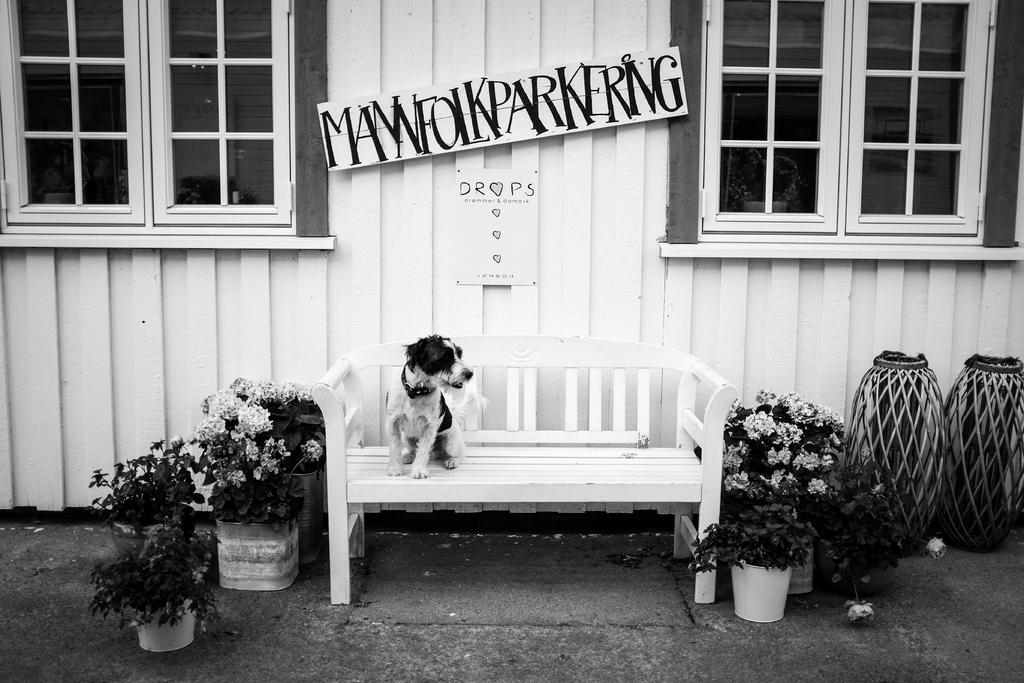What is the dog doing in the image? The dog is on a chair in the image. What other objects or elements can be seen in the image? There are house plants and a window visible in the image. What type of structure is present in the image? There is a wall in the image. How many eyes can be seen on the mice in the image? There are no mice present in the image, so it is not possible to determine the number of eyes on any mice. --- 